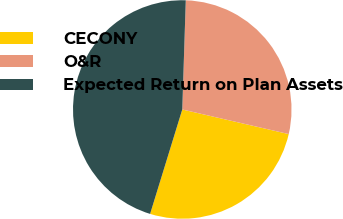Convert chart to OTSL. <chart><loc_0><loc_0><loc_500><loc_500><pie_chart><fcel>CECONY<fcel>O&R<fcel>Expected Return on Plan Assets<nl><fcel>26.14%<fcel>28.1%<fcel>45.75%<nl></chart> 